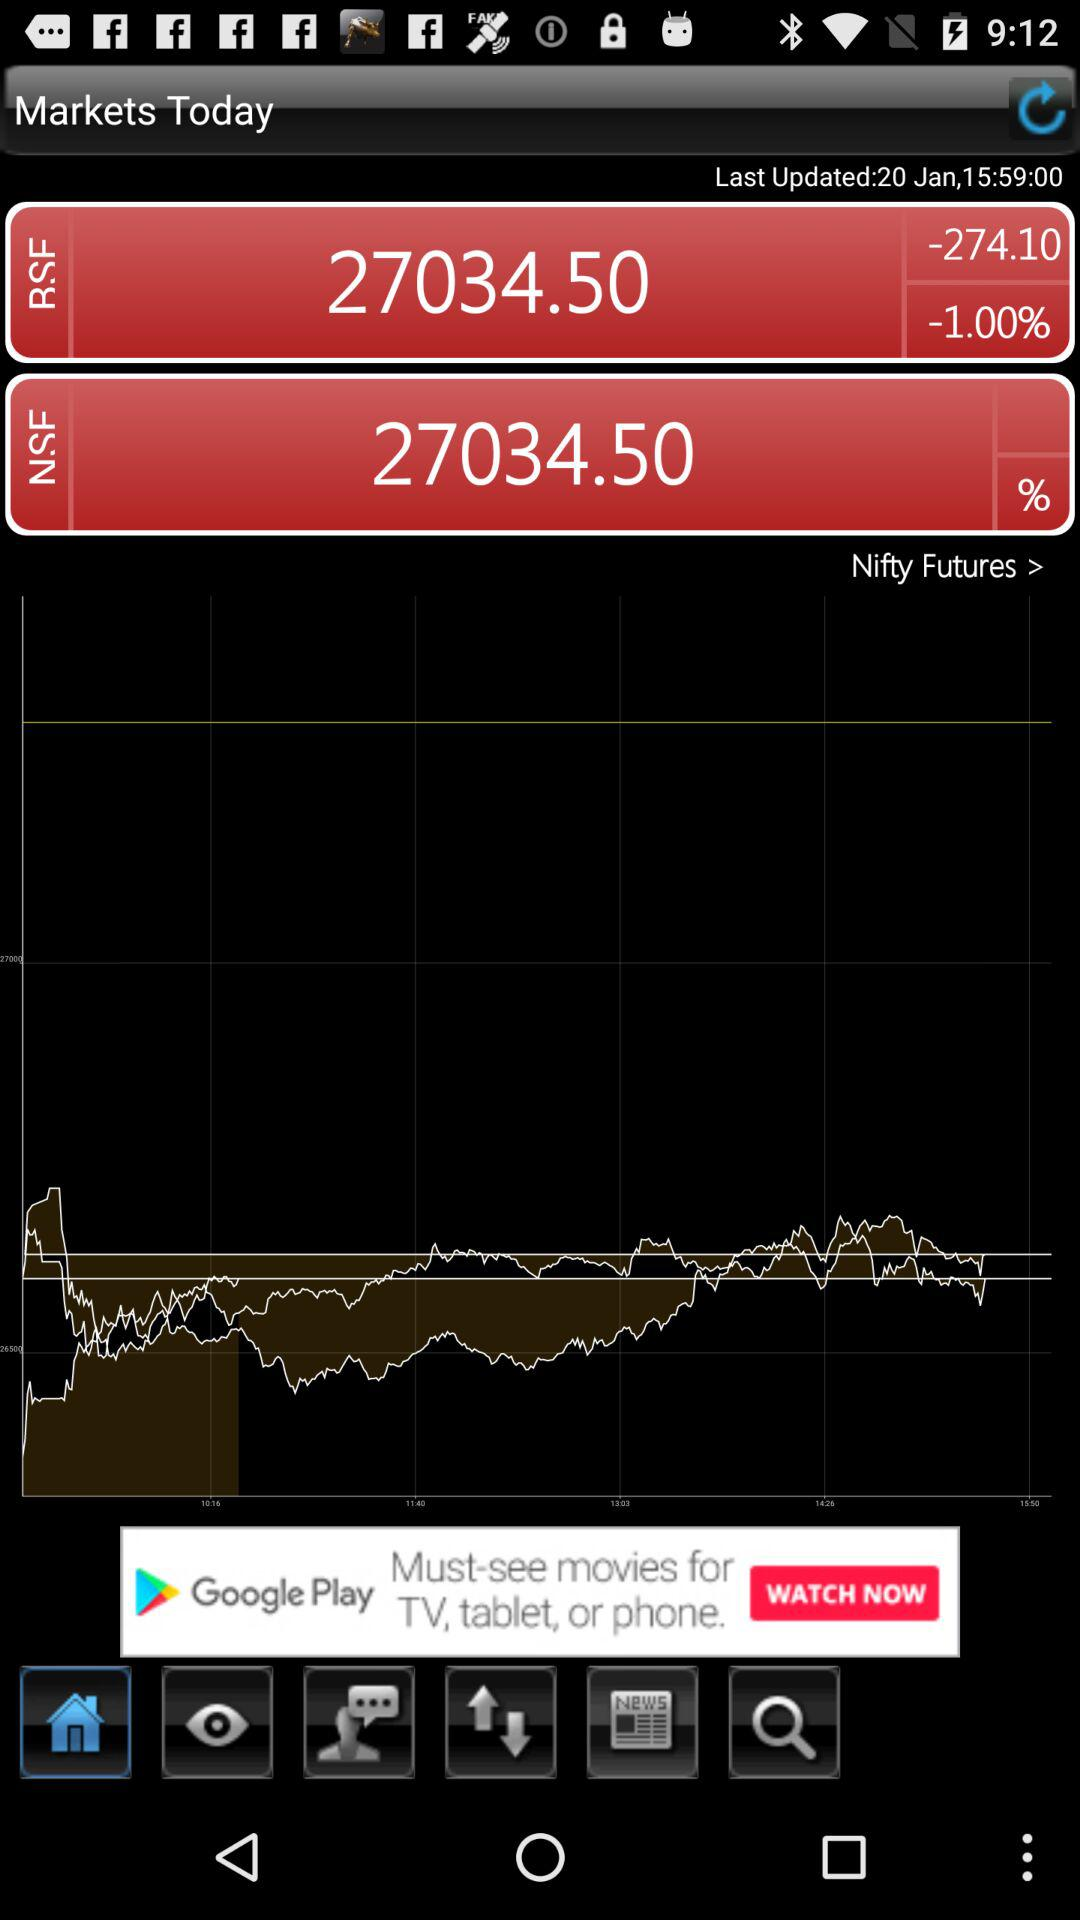When was it last updated? It was last updated on January 20. 